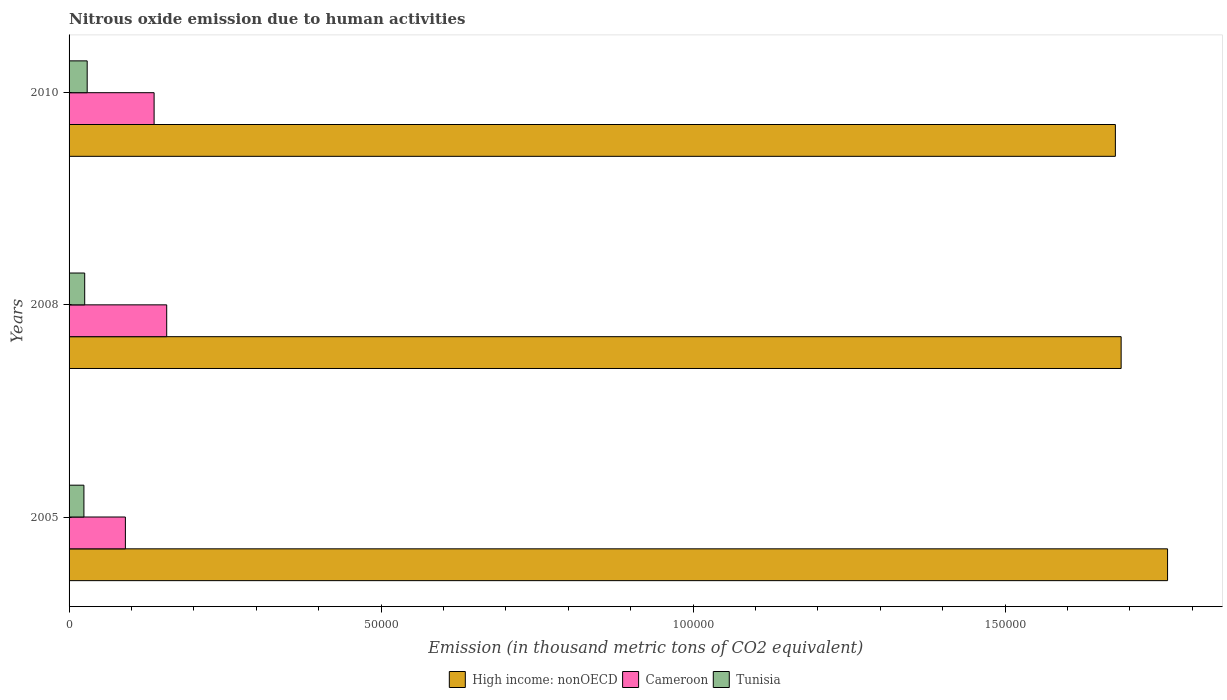How many groups of bars are there?
Give a very brief answer. 3. Are the number of bars on each tick of the Y-axis equal?
Offer a terse response. Yes. How many bars are there on the 2nd tick from the top?
Offer a terse response. 3. How many bars are there on the 2nd tick from the bottom?
Keep it short and to the point. 3. In how many cases, is the number of bars for a given year not equal to the number of legend labels?
Your response must be concise. 0. What is the amount of nitrous oxide emitted in Cameroon in 2010?
Provide a succinct answer. 1.36e+04. Across all years, what is the maximum amount of nitrous oxide emitted in Cameroon?
Make the answer very short. 1.56e+04. Across all years, what is the minimum amount of nitrous oxide emitted in High income: nonOECD?
Your answer should be very brief. 1.68e+05. In which year was the amount of nitrous oxide emitted in High income: nonOECD minimum?
Your response must be concise. 2010. What is the total amount of nitrous oxide emitted in Cameroon in the graph?
Provide a short and direct response. 3.83e+04. What is the difference between the amount of nitrous oxide emitted in Cameroon in 2005 and that in 2010?
Provide a succinct answer. -4600.5. What is the difference between the amount of nitrous oxide emitted in Tunisia in 2010 and the amount of nitrous oxide emitted in Cameroon in 2008?
Provide a short and direct response. -1.27e+04. What is the average amount of nitrous oxide emitted in Cameroon per year?
Provide a succinct answer. 1.28e+04. In the year 2008, what is the difference between the amount of nitrous oxide emitted in Cameroon and amount of nitrous oxide emitted in High income: nonOECD?
Your response must be concise. -1.53e+05. What is the ratio of the amount of nitrous oxide emitted in Cameroon in 2005 to that in 2008?
Give a very brief answer. 0.58. Is the difference between the amount of nitrous oxide emitted in Cameroon in 2005 and 2010 greater than the difference between the amount of nitrous oxide emitted in High income: nonOECD in 2005 and 2010?
Your answer should be compact. No. What is the difference between the highest and the second highest amount of nitrous oxide emitted in Tunisia?
Provide a succinct answer. 398.1. What is the difference between the highest and the lowest amount of nitrous oxide emitted in High income: nonOECD?
Offer a terse response. 8364.9. What does the 1st bar from the top in 2005 represents?
Your answer should be very brief. Tunisia. What does the 3rd bar from the bottom in 2005 represents?
Keep it short and to the point. Tunisia. Is it the case that in every year, the sum of the amount of nitrous oxide emitted in High income: nonOECD and amount of nitrous oxide emitted in Tunisia is greater than the amount of nitrous oxide emitted in Cameroon?
Provide a short and direct response. Yes. How many bars are there?
Provide a succinct answer. 9. Are all the bars in the graph horizontal?
Give a very brief answer. Yes. What is the difference between two consecutive major ticks on the X-axis?
Your response must be concise. 5.00e+04. Are the values on the major ticks of X-axis written in scientific E-notation?
Your answer should be compact. No. Where does the legend appear in the graph?
Offer a very short reply. Bottom center. How are the legend labels stacked?
Your answer should be compact. Horizontal. What is the title of the graph?
Your answer should be compact. Nitrous oxide emission due to human activities. Does "South Asia" appear as one of the legend labels in the graph?
Keep it short and to the point. No. What is the label or title of the X-axis?
Offer a very short reply. Emission (in thousand metric tons of CO2 equivalent). What is the Emission (in thousand metric tons of CO2 equivalent) of High income: nonOECD in 2005?
Provide a succinct answer. 1.76e+05. What is the Emission (in thousand metric tons of CO2 equivalent) in Cameroon in 2005?
Your answer should be compact. 9027.2. What is the Emission (in thousand metric tons of CO2 equivalent) in Tunisia in 2005?
Give a very brief answer. 2379.7. What is the Emission (in thousand metric tons of CO2 equivalent) in High income: nonOECD in 2008?
Your response must be concise. 1.69e+05. What is the Emission (in thousand metric tons of CO2 equivalent) in Cameroon in 2008?
Give a very brief answer. 1.56e+04. What is the Emission (in thousand metric tons of CO2 equivalent) in Tunisia in 2008?
Your response must be concise. 2506.4. What is the Emission (in thousand metric tons of CO2 equivalent) of High income: nonOECD in 2010?
Offer a terse response. 1.68e+05. What is the Emission (in thousand metric tons of CO2 equivalent) of Cameroon in 2010?
Your answer should be compact. 1.36e+04. What is the Emission (in thousand metric tons of CO2 equivalent) of Tunisia in 2010?
Offer a terse response. 2904.5. Across all years, what is the maximum Emission (in thousand metric tons of CO2 equivalent) of High income: nonOECD?
Ensure brevity in your answer.  1.76e+05. Across all years, what is the maximum Emission (in thousand metric tons of CO2 equivalent) of Cameroon?
Provide a succinct answer. 1.56e+04. Across all years, what is the maximum Emission (in thousand metric tons of CO2 equivalent) of Tunisia?
Give a very brief answer. 2904.5. Across all years, what is the minimum Emission (in thousand metric tons of CO2 equivalent) in High income: nonOECD?
Your response must be concise. 1.68e+05. Across all years, what is the minimum Emission (in thousand metric tons of CO2 equivalent) in Cameroon?
Provide a short and direct response. 9027.2. Across all years, what is the minimum Emission (in thousand metric tons of CO2 equivalent) in Tunisia?
Offer a very short reply. 2379.7. What is the total Emission (in thousand metric tons of CO2 equivalent) in High income: nonOECD in the graph?
Ensure brevity in your answer.  5.12e+05. What is the total Emission (in thousand metric tons of CO2 equivalent) of Cameroon in the graph?
Your answer should be very brief. 3.83e+04. What is the total Emission (in thousand metric tons of CO2 equivalent) in Tunisia in the graph?
Provide a succinct answer. 7790.6. What is the difference between the Emission (in thousand metric tons of CO2 equivalent) of High income: nonOECD in 2005 and that in 2008?
Make the answer very short. 7440. What is the difference between the Emission (in thousand metric tons of CO2 equivalent) of Cameroon in 2005 and that in 2008?
Ensure brevity in your answer.  -6619.5. What is the difference between the Emission (in thousand metric tons of CO2 equivalent) of Tunisia in 2005 and that in 2008?
Make the answer very short. -126.7. What is the difference between the Emission (in thousand metric tons of CO2 equivalent) in High income: nonOECD in 2005 and that in 2010?
Offer a terse response. 8364.9. What is the difference between the Emission (in thousand metric tons of CO2 equivalent) in Cameroon in 2005 and that in 2010?
Your answer should be very brief. -4600.5. What is the difference between the Emission (in thousand metric tons of CO2 equivalent) of Tunisia in 2005 and that in 2010?
Keep it short and to the point. -524.8. What is the difference between the Emission (in thousand metric tons of CO2 equivalent) of High income: nonOECD in 2008 and that in 2010?
Your response must be concise. 924.9. What is the difference between the Emission (in thousand metric tons of CO2 equivalent) of Cameroon in 2008 and that in 2010?
Provide a short and direct response. 2019. What is the difference between the Emission (in thousand metric tons of CO2 equivalent) of Tunisia in 2008 and that in 2010?
Your answer should be compact. -398.1. What is the difference between the Emission (in thousand metric tons of CO2 equivalent) in High income: nonOECD in 2005 and the Emission (in thousand metric tons of CO2 equivalent) in Cameroon in 2008?
Your answer should be compact. 1.60e+05. What is the difference between the Emission (in thousand metric tons of CO2 equivalent) in High income: nonOECD in 2005 and the Emission (in thousand metric tons of CO2 equivalent) in Tunisia in 2008?
Your response must be concise. 1.74e+05. What is the difference between the Emission (in thousand metric tons of CO2 equivalent) in Cameroon in 2005 and the Emission (in thousand metric tons of CO2 equivalent) in Tunisia in 2008?
Provide a succinct answer. 6520.8. What is the difference between the Emission (in thousand metric tons of CO2 equivalent) of High income: nonOECD in 2005 and the Emission (in thousand metric tons of CO2 equivalent) of Cameroon in 2010?
Your answer should be very brief. 1.62e+05. What is the difference between the Emission (in thousand metric tons of CO2 equivalent) in High income: nonOECD in 2005 and the Emission (in thousand metric tons of CO2 equivalent) in Tunisia in 2010?
Your answer should be compact. 1.73e+05. What is the difference between the Emission (in thousand metric tons of CO2 equivalent) of Cameroon in 2005 and the Emission (in thousand metric tons of CO2 equivalent) of Tunisia in 2010?
Provide a succinct answer. 6122.7. What is the difference between the Emission (in thousand metric tons of CO2 equivalent) in High income: nonOECD in 2008 and the Emission (in thousand metric tons of CO2 equivalent) in Cameroon in 2010?
Make the answer very short. 1.55e+05. What is the difference between the Emission (in thousand metric tons of CO2 equivalent) of High income: nonOECD in 2008 and the Emission (in thousand metric tons of CO2 equivalent) of Tunisia in 2010?
Your response must be concise. 1.66e+05. What is the difference between the Emission (in thousand metric tons of CO2 equivalent) of Cameroon in 2008 and the Emission (in thousand metric tons of CO2 equivalent) of Tunisia in 2010?
Offer a very short reply. 1.27e+04. What is the average Emission (in thousand metric tons of CO2 equivalent) in High income: nonOECD per year?
Offer a terse response. 1.71e+05. What is the average Emission (in thousand metric tons of CO2 equivalent) in Cameroon per year?
Make the answer very short. 1.28e+04. What is the average Emission (in thousand metric tons of CO2 equivalent) of Tunisia per year?
Keep it short and to the point. 2596.87. In the year 2005, what is the difference between the Emission (in thousand metric tons of CO2 equivalent) of High income: nonOECD and Emission (in thousand metric tons of CO2 equivalent) of Cameroon?
Ensure brevity in your answer.  1.67e+05. In the year 2005, what is the difference between the Emission (in thousand metric tons of CO2 equivalent) of High income: nonOECD and Emission (in thousand metric tons of CO2 equivalent) of Tunisia?
Your answer should be compact. 1.74e+05. In the year 2005, what is the difference between the Emission (in thousand metric tons of CO2 equivalent) in Cameroon and Emission (in thousand metric tons of CO2 equivalent) in Tunisia?
Offer a very short reply. 6647.5. In the year 2008, what is the difference between the Emission (in thousand metric tons of CO2 equivalent) of High income: nonOECD and Emission (in thousand metric tons of CO2 equivalent) of Cameroon?
Provide a succinct answer. 1.53e+05. In the year 2008, what is the difference between the Emission (in thousand metric tons of CO2 equivalent) in High income: nonOECD and Emission (in thousand metric tons of CO2 equivalent) in Tunisia?
Your answer should be very brief. 1.66e+05. In the year 2008, what is the difference between the Emission (in thousand metric tons of CO2 equivalent) in Cameroon and Emission (in thousand metric tons of CO2 equivalent) in Tunisia?
Provide a succinct answer. 1.31e+04. In the year 2010, what is the difference between the Emission (in thousand metric tons of CO2 equivalent) in High income: nonOECD and Emission (in thousand metric tons of CO2 equivalent) in Cameroon?
Your answer should be compact. 1.54e+05. In the year 2010, what is the difference between the Emission (in thousand metric tons of CO2 equivalent) of High income: nonOECD and Emission (in thousand metric tons of CO2 equivalent) of Tunisia?
Make the answer very short. 1.65e+05. In the year 2010, what is the difference between the Emission (in thousand metric tons of CO2 equivalent) of Cameroon and Emission (in thousand metric tons of CO2 equivalent) of Tunisia?
Your answer should be very brief. 1.07e+04. What is the ratio of the Emission (in thousand metric tons of CO2 equivalent) of High income: nonOECD in 2005 to that in 2008?
Offer a very short reply. 1.04. What is the ratio of the Emission (in thousand metric tons of CO2 equivalent) in Cameroon in 2005 to that in 2008?
Give a very brief answer. 0.58. What is the ratio of the Emission (in thousand metric tons of CO2 equivalent) of Tunisia in 2005 to that in 2008?
Give a very brief answer. 0.95. What is the ratio of the Emission (in thousand metric tons of CO2 equivalent) in High income: nonOECD in 2005 to that in 2010?
Make the answer very short. 1.05. What is the ratio of the Emission (in thousand metric tons of CO2 equivalent) in Cameroon in 2005 to that in 2010?
Offer a very short reply. 0.66. What is the ratio of the Emission (in thousand metric tons of CO2 equivalent) of Tunisia in 2005 to that in 2010?
Give a very brief answer. 0.82. What is the ratio of the Emission (in thousand metric tons of CO2 equivalent) of Cameroon in 2008 to that in 2010?
Give a very brief answer. 1.15. What is the ratio of the Emission (in thousand metric tons of CO2 equivalent) in Tunisia in 2008 to that in 2010?
Your answer should be compact. 0.86. What is the difference between the highest and the second highest Emission (in thousand metric tons of CO2 equivalent) of High income: nonOECD?
Make the answer very short. 7440. What is the difference between the highest and the second highest Emission (in thousand metric tons of CO2 equivalent) in Cameroon?
Make the answer very short. 2019. What is the difference between the highest and the second highest Emission (in thousand metric tons of CO2 equivalent) in Tunisia?
Offer a very short reply. 398.1. What is the difference between the highest and the lowest Emission (in thousand metric tons of CO2 equivalent) in High income: nonOECD?
Give a very brief answer. 8364.9. What is the difference between the highest and the lowest Emission (in thousand metric tons of CO2 equivalent) of Cameroon?
Your answer should be compact. 6619.5. What is the difference between the highest and the lowest Emission (in thousand metric tons of CO2 equivalent) of Tunisia?
Your answer should be compact. 524.8. 